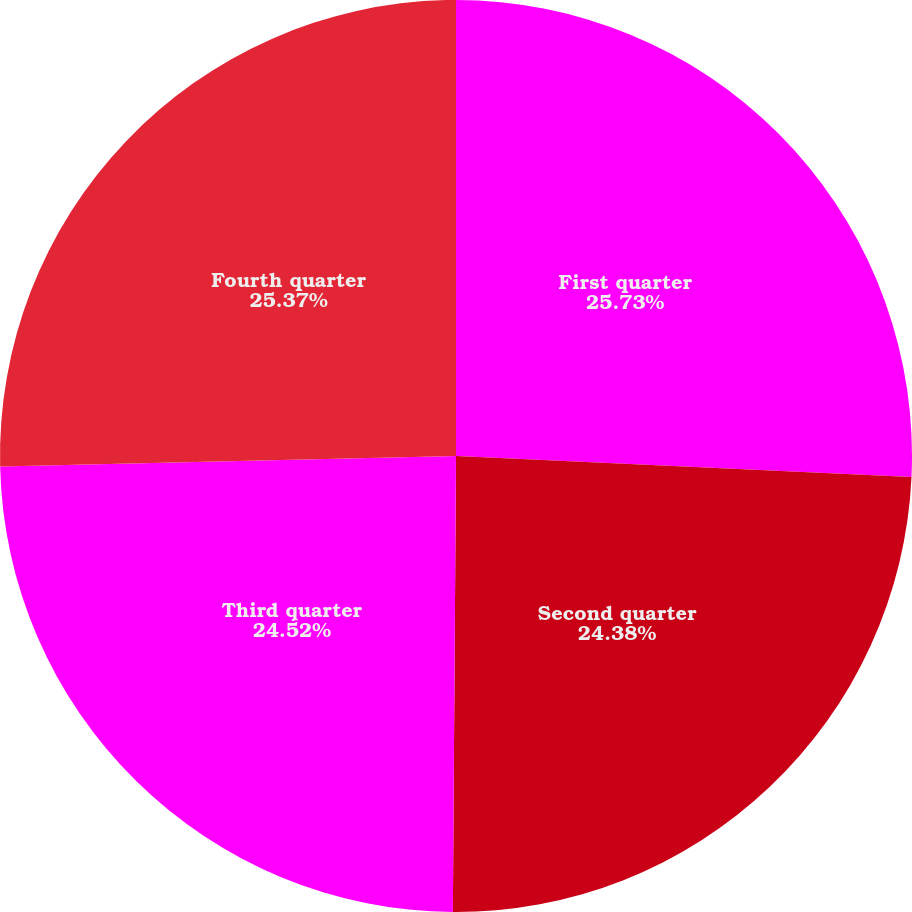Convert chart to OTSL. <chart><loc_0><loc_0><loc_500><loc_500><pie_chart><fcel>First quarter<fcel>Second quarter<fcel>Third quarter<fcel>Fourth quarter<nl><fcel>25.73%<fcel>24.38%<fcel>24.52%<fcel>25.37%<nl></chart> 